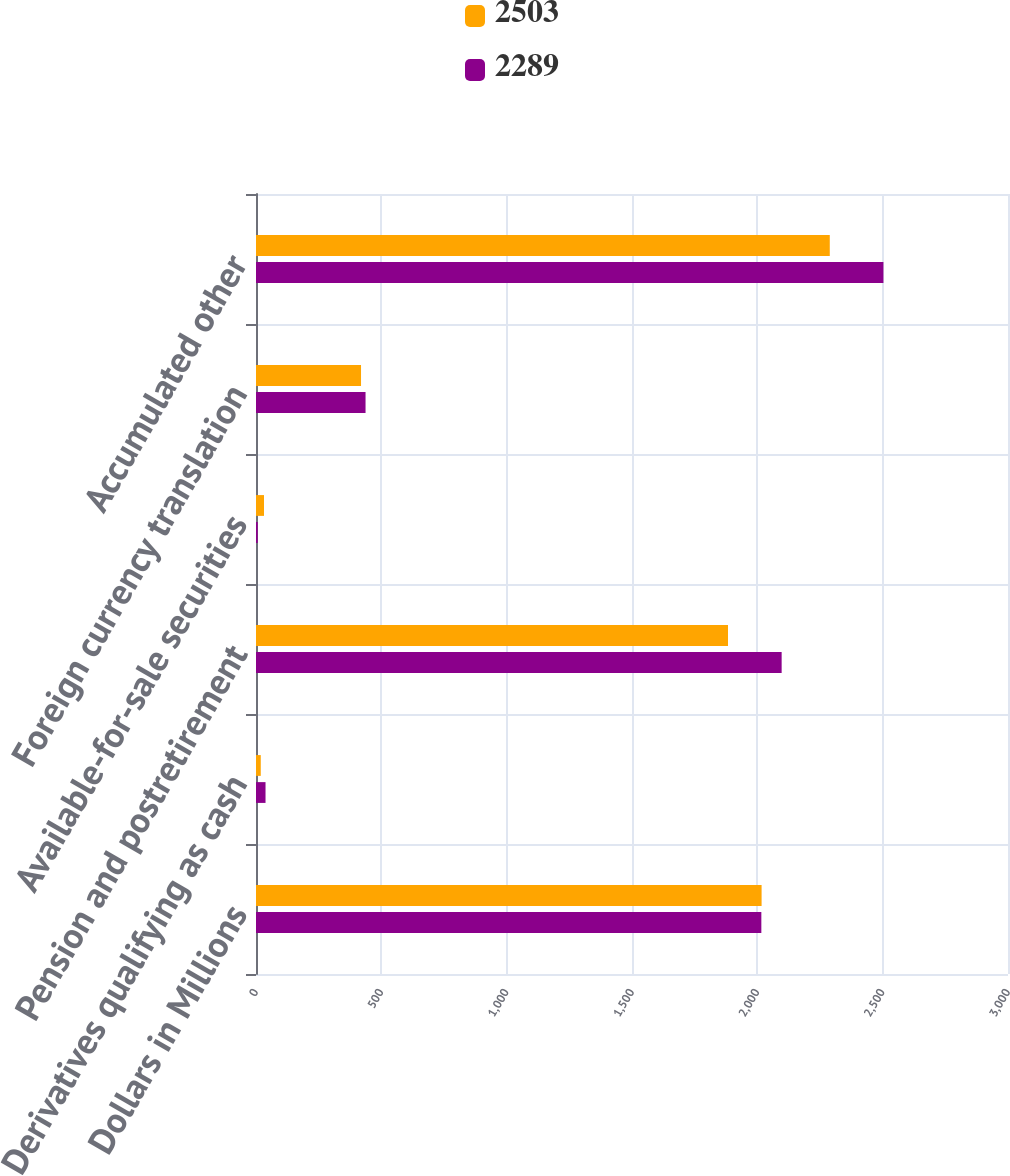Convert chart. <chart><loc_0><loc_0><loc_500><loc_500><stacked_bar_chart><ecel><fcel>Dollars in Millions<fcel>Derivatives qualifying as cash<fcel>Pension and postretirement<fcel>Available-for-sale securities<fcel>Foreign currency translation<fcel>Accumulated other<nl><fcel>2503<fcel>2017<fcel>19<fcel>1883<fcel>32<fcel>419<fcel>2289<nl><fcel>2289<fcel>2016<fcel>38<fcel>2097<fcel>7<fcel>437<fcel>2503<nl></chart> 